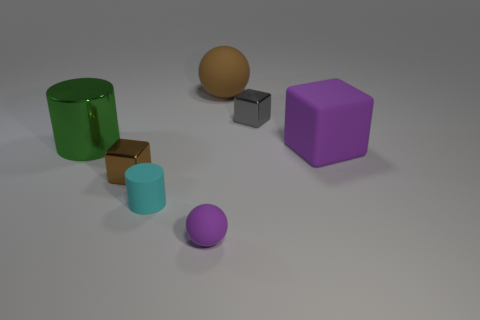There is a large rubber thing in front of the metallic cylinder; is it the same color as the tiny matte cylinder?
Give a very brief answer. No. Is there any other thing that has the same shape as the small gray thing?
Keep it short and to the point. Yes. There is a large thing on the right side of the gray metallic thing; is there a large brown object behind it?
Give a very brief answer. Yes. Are there fewer tiny objects on the right side of the small gray cube than large cylinders behind the big green object?
Make the answer very short. No. There is a purple rubber object right of the shiny block behind the small metal cube to the left of the gray metallic object; what is its size?
Give a very brief answer. Large. Is the size of the ball behind the gray cube the same as the large metal cylinder?
Provide a short and direct response. Yes. How many other things are made of the same material as the green cylinder?
Provide a succinct answer. 2. Are there more tiny gray metallic blocks than yellow balls?
Ensure brevity in your answer.  Yes. The tiny block that is in front of the tiny shiny block that is behind the small cube that is in front of the large purple cube is made of what material?
Give a very brief answer. Metal. Is the matte cube the same color as the matte cylinder?
Provide a short and direct response. No. 